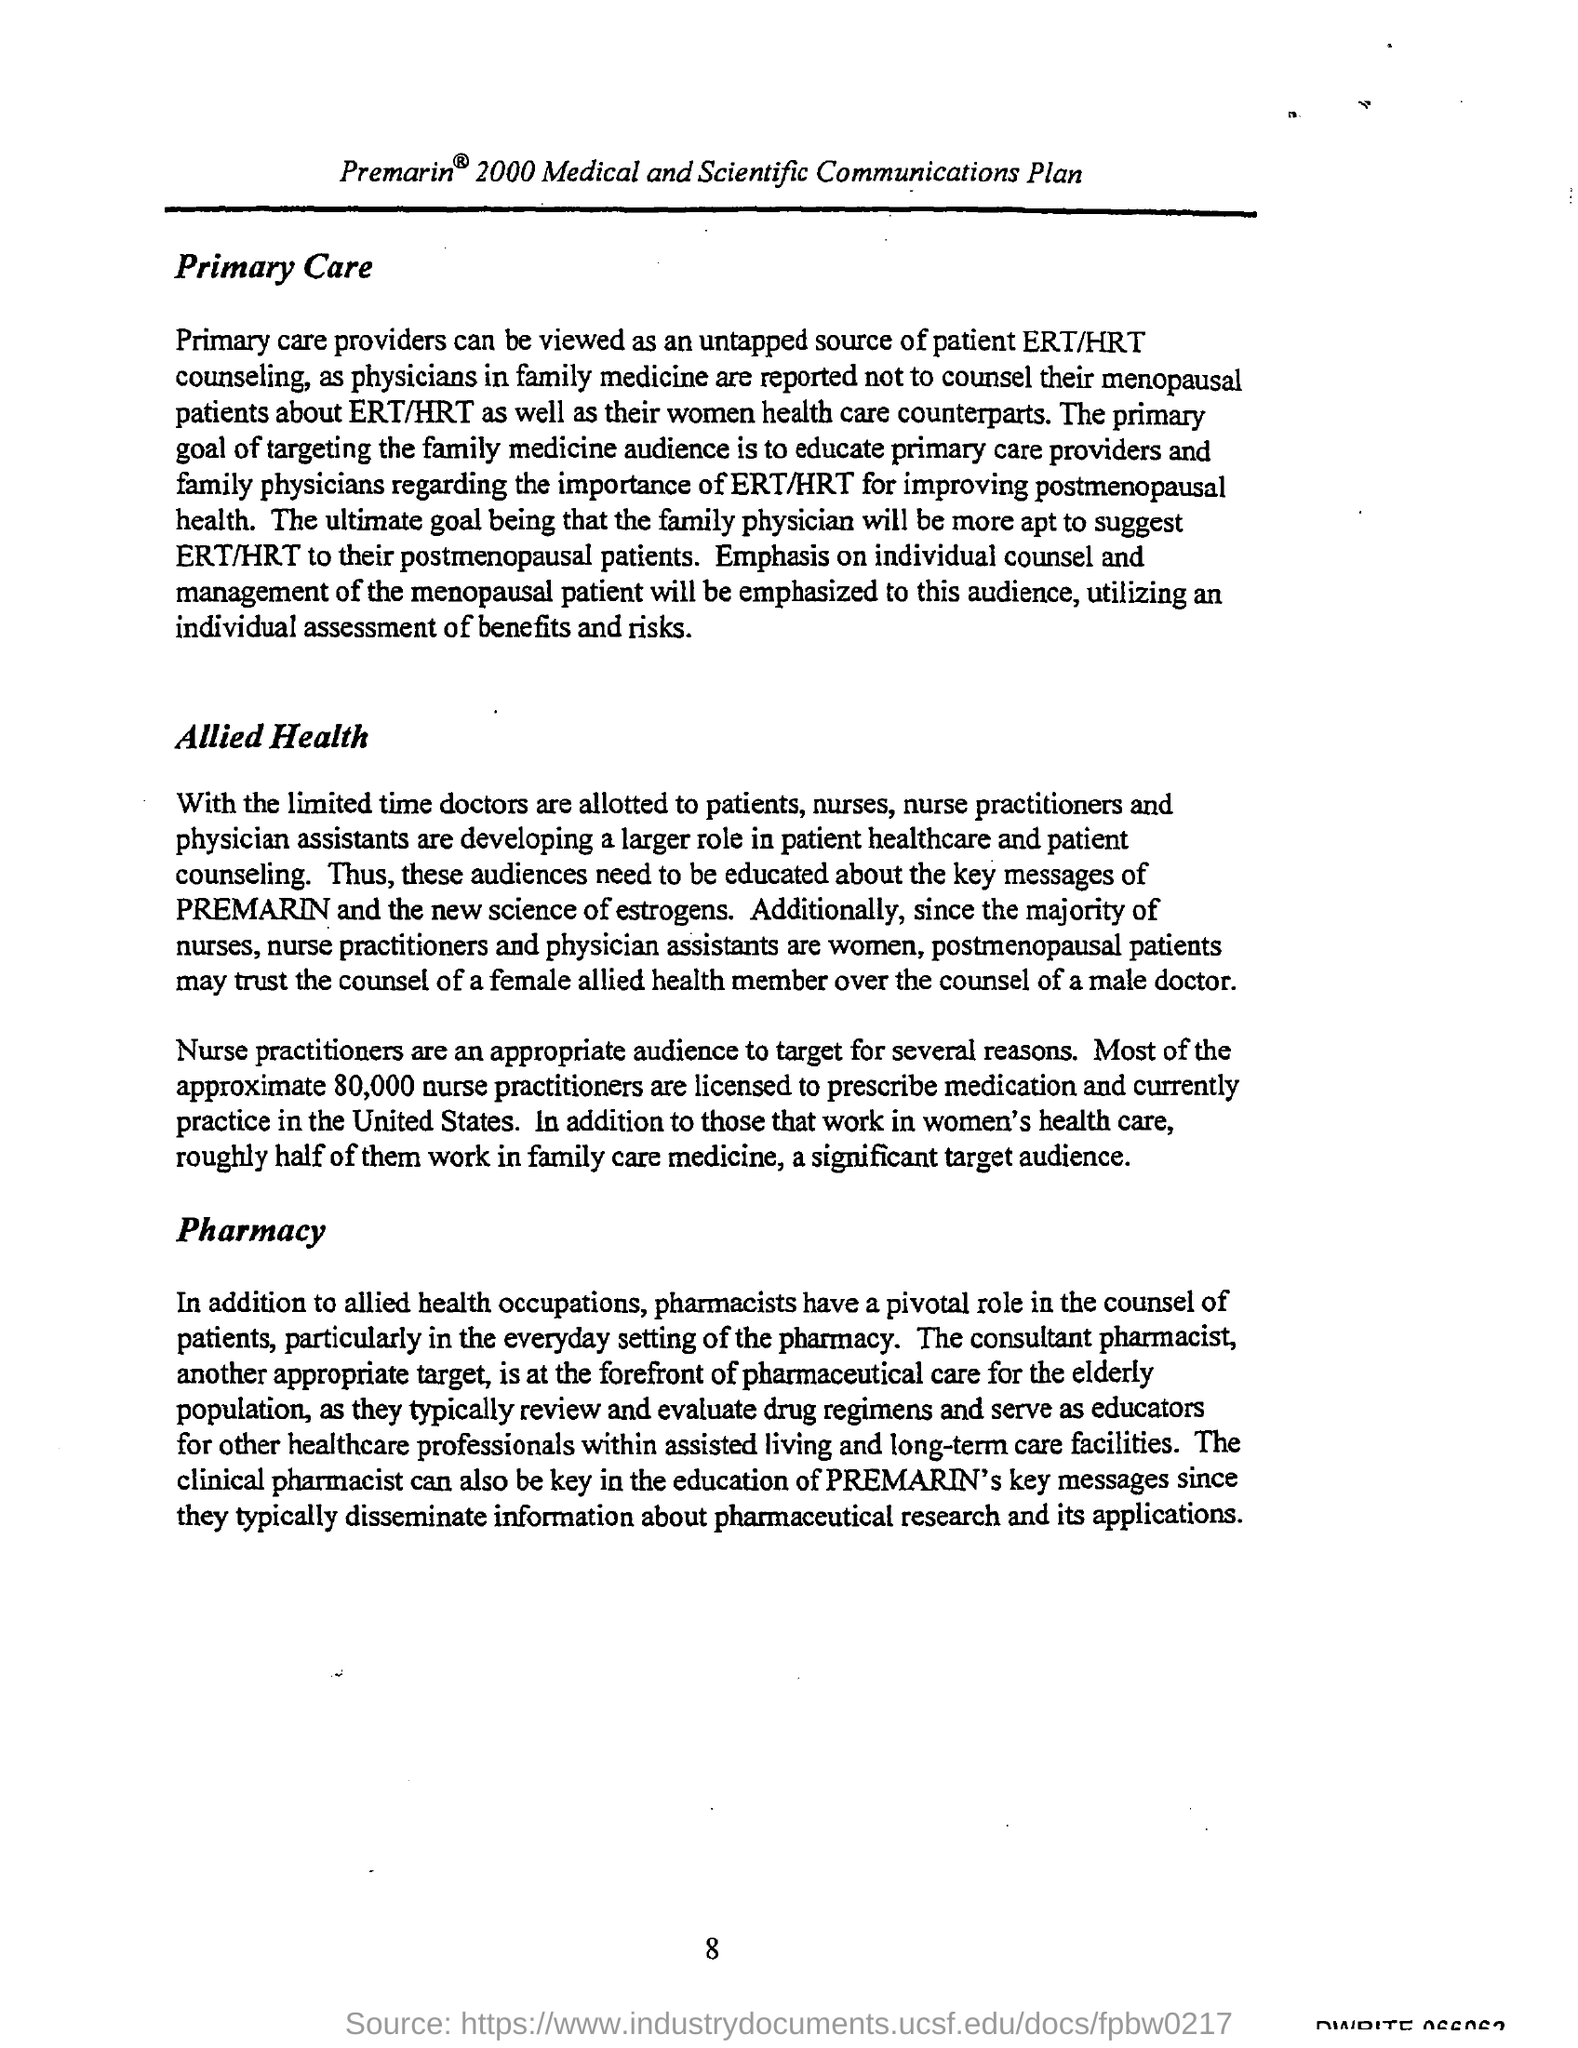Who are an appropriate audience to target for several reasons?
Make the answer very short. Nurse practitioners. What is the approximate number of nurse practitioners that are licensed to prescribe medication?
Your answer should be very brief. 80,000. 